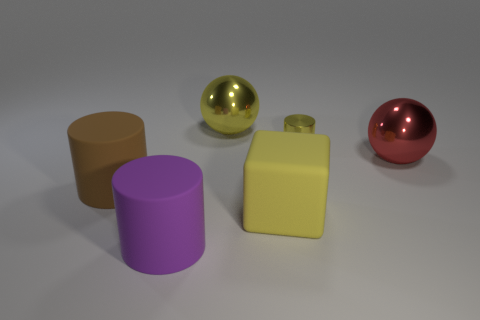Is there anything else that has the same size as the yellow metal cylinder?
Provide a short and direct response. No. The other sphere that is the same material as the red ball is what color?
Provide a short and direct response. Yellow. Is the number of large brown matte objects right of the big red ball less than the number of things in front of the shiny cylinder?
Ensure brevity in your answer.  Yes. How many cylinders have the same color as the small object?
Make the answer very short. 0. There is a cube that is the same color as the shiny cylinder; what material is it?
Make the answer very short. Rubber. What number of things are left of the matte block and to the right of the brown thing?
Offer a very short reply. 2. What material is the big yellow object in front of the big shiny sphere that is right of the big yellow metal ball?
Give a very brief answer. Rubber. Are there any big purple cylinders that have the same material as the big purple object?
Provide a short and direct response. No. There is a red object that is the same size as the brown rubber cylinder; what is its material?
Your answer should be very brief. Metal. What size is the cylinder that is behind the large rubber object that is on the left side of the matte cylinder that is in front of the big cube?
Give a very brief answer. Small. 